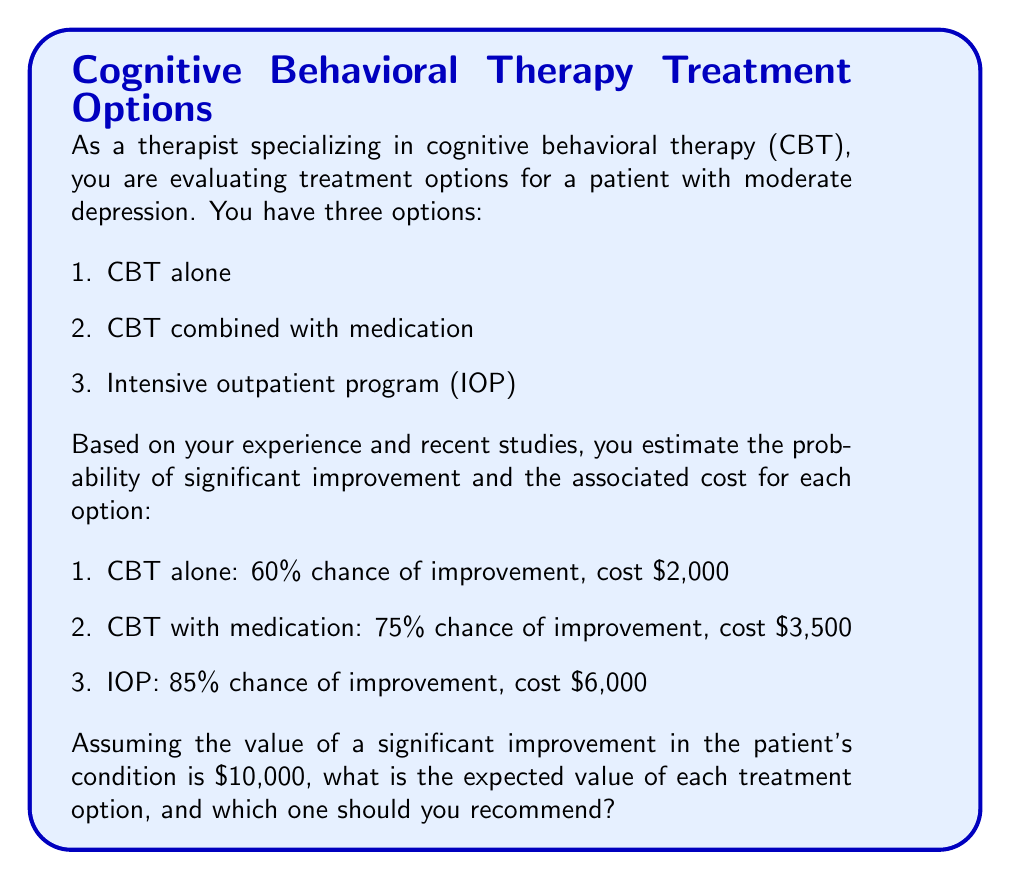Help me with this question. To solve this problem, we need to calculate the expected value for each treatment option using the formula:

$$ E(X) = P(success) \times Value_{success} + P(failure) \times Value_{failure} - Cost $$

Where:
- $E(X)$ is the expected value
- $P(success)$ is the probability of significant improvement
- $Value_{success}$ is the value of significant improvement ($10,000)
- $P(failure)$ is the probability of no significant improvement (1 - $P(success)$)
- $Value_{failure}$ is 0 (no additional value if no improvement)
- $Cost$ is the cost of the treatment option

Let's calculate the expected value for each option:

1. CBT alone:
$$ E(CBT) = 0.60 \times 10000 + 0.40 \times 0 - 2000 = 4000 $$

2. CBT with medication:
$$ E(CBT+med) = 0.75 \times 10000 + 0.25 \times 0 - 3500 = 4000 $$

3. Intensive outpatient program (IOP):
$$ E(IOP) = 0.85 \times 10000 + 0.15 \times 0 - 6000 = 2500 $$

The expected values are:
- CBT alone: $4,000
- CBT with medication: $4,000
- IOP: $2,500

Based on these calculations, both CBT alone and CBT with medication have the highest expected value of $4,000. The IOP has a lower expected value despite its higher success rate due to its significantly higher cost.
Answer: The expected values are:
- CBT alone: $4,000
- CBT with medication: $4,000
- IOP: $2,500

You should recommend either CBT alone or CBT with medication, as they both have the highest expected value of $4,000. 